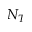Convert formula to latex. <formula><loc_0><loc_0><loc_500><loc_500>N _ { T }</formula> 